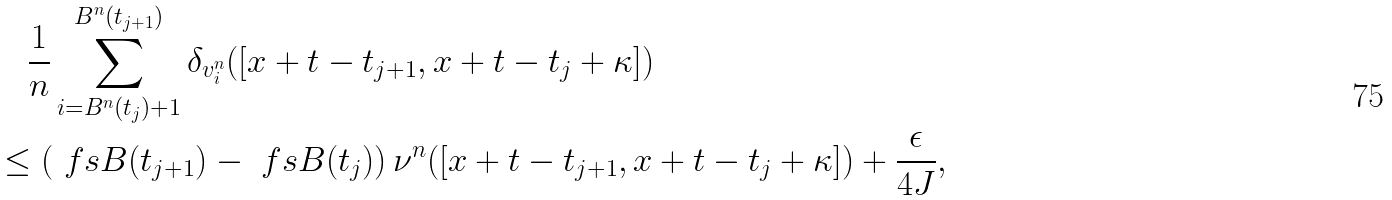Convert formula to latex. <formula><loc_0><loc_0><loc_500><loc_500>& \quad \frac { 1 } { n } \sum _ { i = B ^ { n } ( t _ { j } ) + 1 } ^ { B ^ { n } ( t _ { j + 1 } ) } \delta _ { v ^ { n } _ { i } } ( [ x + t - t _ { j + 1 } , x + t - t _ { j } + \kappa ] ) \\ & \leq \left ( \ f s B ( t _ { j + 1 } ) - \ f s B ( t _ { j } ) \right ) \nu ^ { n } ( [ x + t - t _ { j + 1 } , x + t - t _ { j } + \kappa ] ) + \frac { \epsilon } { 4 J } ,</formula> 